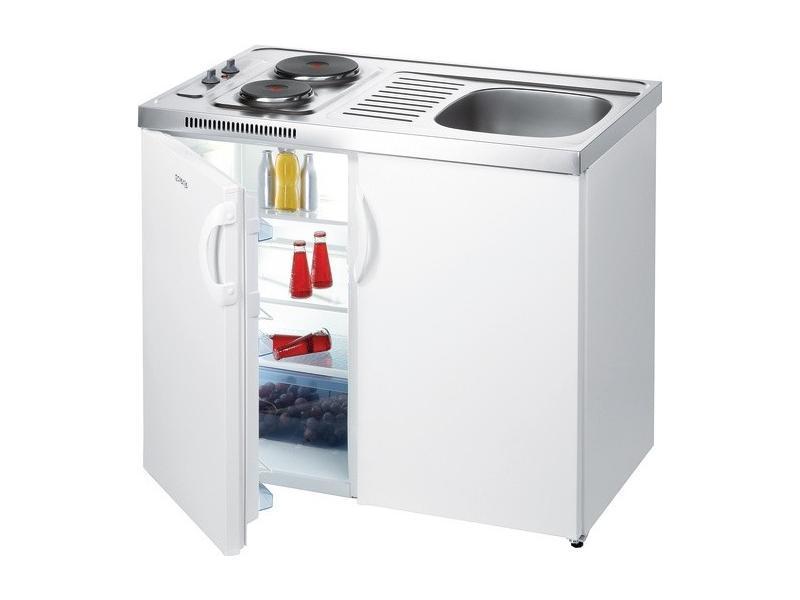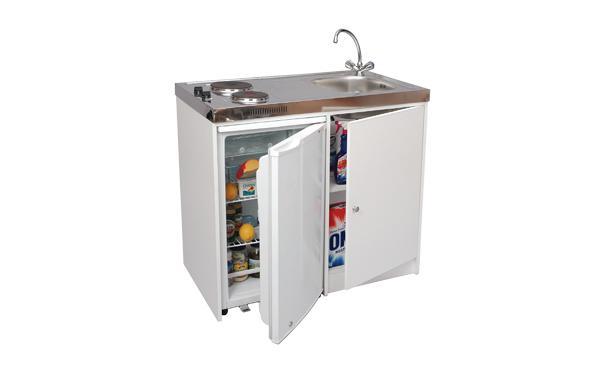The first image is the image on the left, the second image is the image on the right. Assess this claim about the two images: "Only one refrigerator has its door open, and it has no contents within.". Correct or not? Answer yes or no. No. The first image is the image on the left, the second image is the image on the right. Analyze the images presented: Is the assertion "One refrigerator door is all the way wide open and the door shelves are showing." valid? Answer yes or no. No. 